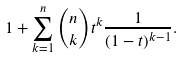Convert formula to latex. <formula><loc_0><loc_0><loc_500><loc_500>1 + \sum _ { k = 1 } ^ { n } { n \choose k } t ^ { k } \frac { 1 } { ( 1 - t ) ^ { k - 1 } } .</formula> 